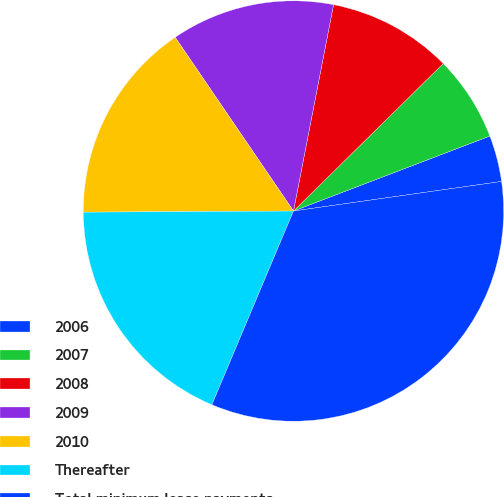<chart> <loc_0><loc_0><loc_500><loc_500><pie_chart><fcel>2006<fcel>2007<fcel>2008<fcel>2009<fcel>2010<fcel>Thereafter<fcel>Total minimum lease payments<nl><fcel>3.56%<fcel>6.57%<fcel>9.57%<fcel>12.57%<fcel>15.57%<fcel>18.57%<fcel>33.59%<nl></chart> 